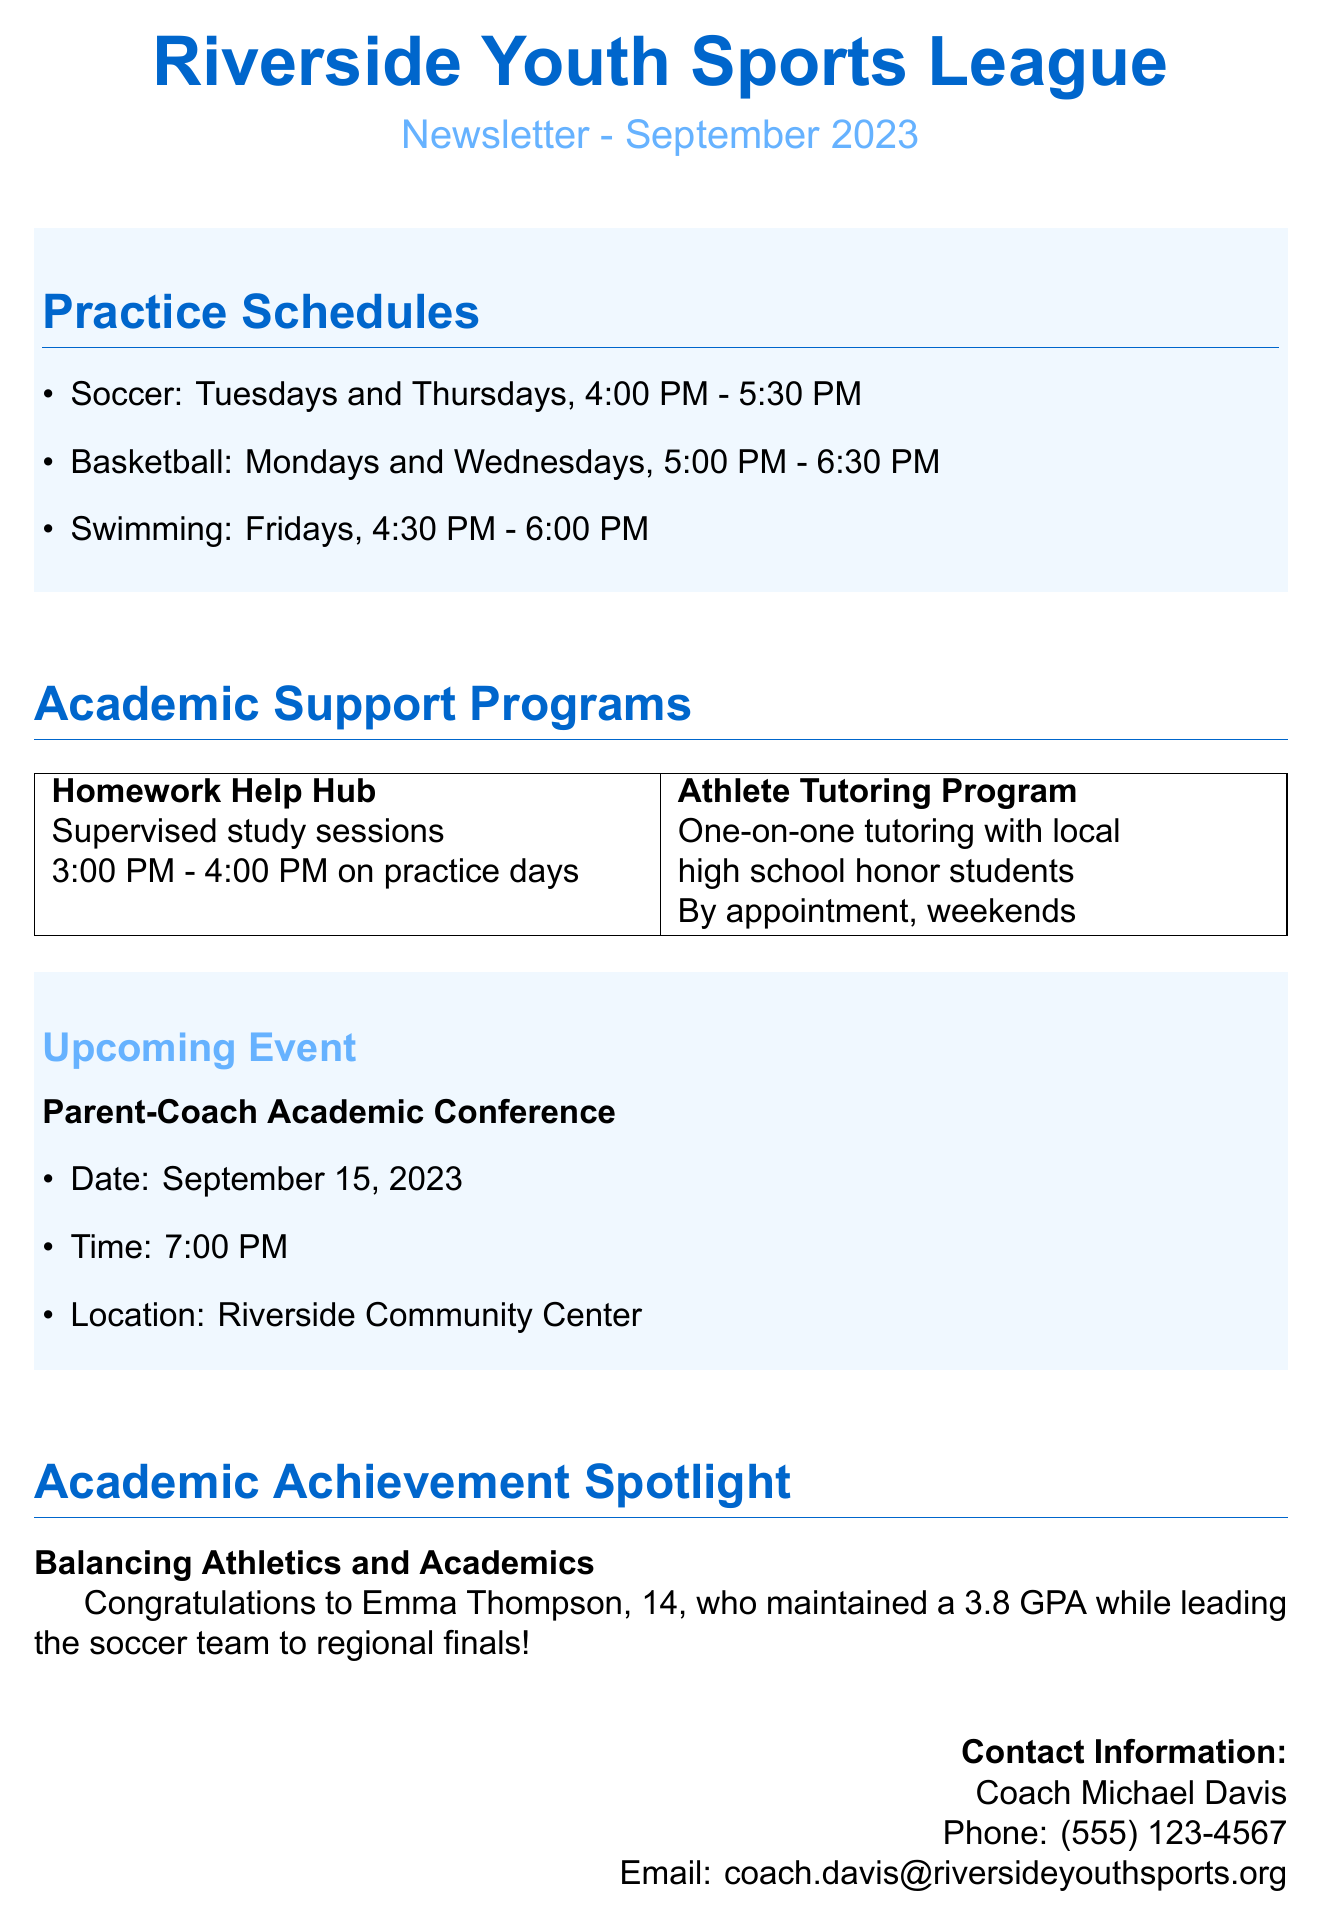What is the title of the newsletter? The title is provided at the beginning of the document.
Answer: Riverside Youth Sports League Newsletter - September 2023 When is the Parent-Coach Academic Conference? The date and time of the conference are specified in the upcoming events section.
Answer: September 15, 2023 What time does swimming practice end? The practice schedule outlines the end time for swimming.
Answer: 6:00 PM Who is featured in the Academic Achievement Spotlight? The spotlight section names the athlete and highlights their accomplishment.
Answer: Emma Thompson What program offers supervised study sessions before practices? The academic support programs detail various initiatives available for student-athletes.
Answer: Homework Help Hub How many days a week does soccer practice occur? The practice schedule indicates the frequency of soccer practices.
Answer: Two days What is the contact email for Coach Michael Davis? The contact information provides the email address for the coach.
Answer: coach.davis@riversideyouthsports.org What is the GPA maintained by Emma Thompson? The achievement spotlight clearly states Emma Thompson's GPA.
Answer: 3.8 What days of the week are basketball practices held? The practice schedule lists the days designated for basketball practice.
Answer: Mondays and Wednesdays 